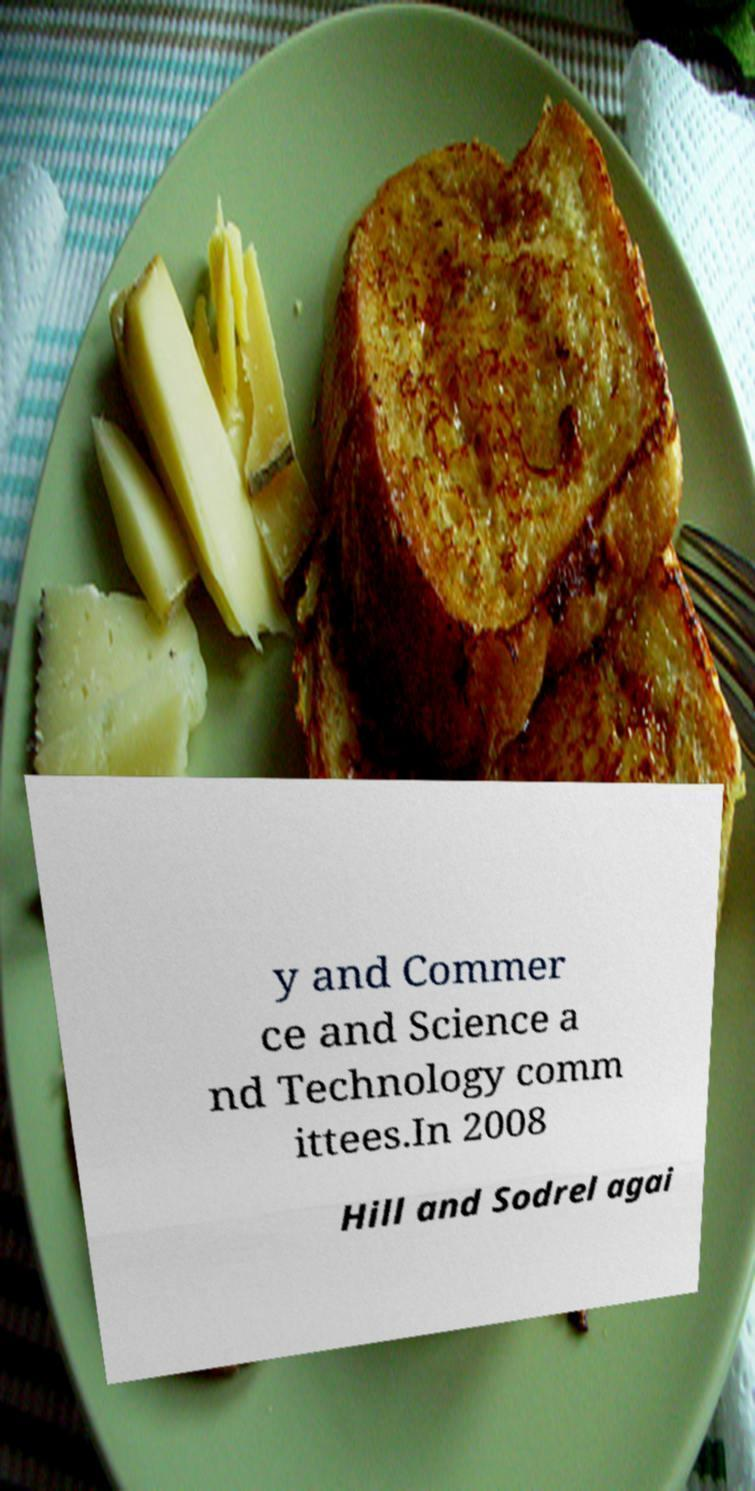Could you assist in decoding the text presented in this image and type it out clearly? y and Commer ce and Science a nd Technology comm ittees.In 2008 Hill and Sodrel agai 